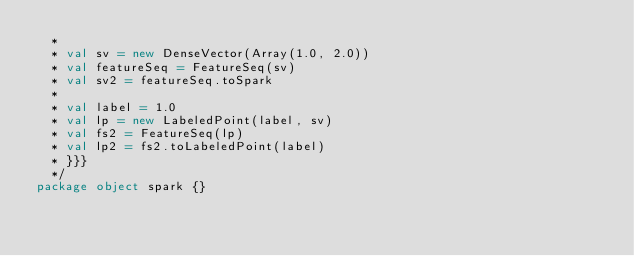<code> <loc_0><loc_0><loc_500><loc_500><_Scala_>  *
  * val sv = new DenseVector(Array(1.0, 2.0))
  * val featureSeq = FeatureSeq(sv)
  * val sv2 = featureSeq.toSpark
  *
  * val label = 1.0
  * val lp = new LabeledPoint(label, sv)
  * val fs2 = FeatureSeq(lp)
  * val lp2 = fs2.toLabeledPoint(label)
  * }}}
  */
package object spark {}
</code> 